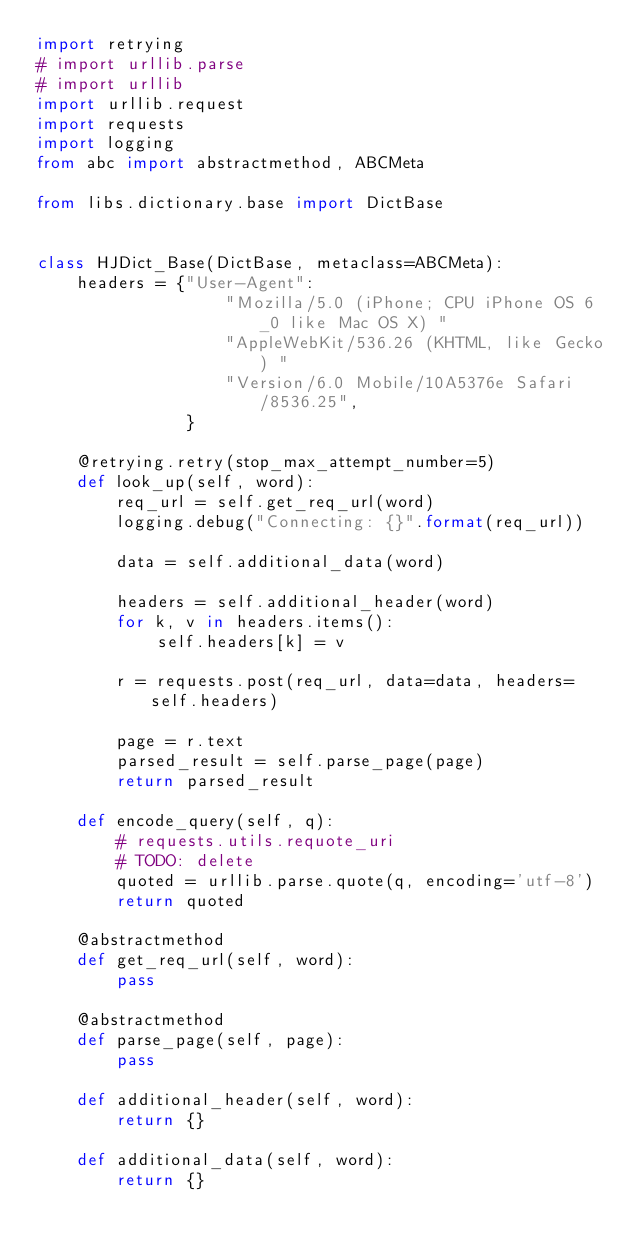<code> <loc_0><loc_0><loc_500><loc_500><_Python_>import retrying
# import urllib.parse
# import urllib
import urllib.request
import requests
import logging
from abc import abstractmethod, ABCMeta

from libs.dictionary.base import DictBase


class HJDict_Base(DictBase, metaclass=ABCMeta):
    headers = {"User-Agent":
                   "Mozilla/5.0 (iPhone; CPU iPhone OS 6_0 like Mac OS X) "
                   "AppleWebKit/536.26 (KHTML, like Gecko) "
                   "Version/6.0 Mobile/10A5376e Safari/8536.25",
               }

    @retrying.retry(stop_max_attempt_number=5)
    def look_up(self, word):
        req_url = self.get_req_url(word)
        logging.debug("Connecting: {}".format(req_url))

        data = self.additional_data(word)

        headers = self.additional_header(word)
        for k, v in headers.items():
            self.headers[k] = v

        r = requests.post(req_url, data=data, headers=self.headers)

        page = r.text
        parsed_result = self.parse_page(page)
        return parsed_result

    def encode_query(self, q):
        # requests.utils.requote_uri
        # TODO: delete
        quoted = urllib.parse.quote(q, encoding='utf-8')
        return quoted

    @abstractmethod
    def get_req_url(self, word):
        pass

    @abstractmethod
    def parse_page(self, page):
        pass

    def additional_header(self, word):
        return {}

    def additional_data(self, word):
        return {}

</code> 